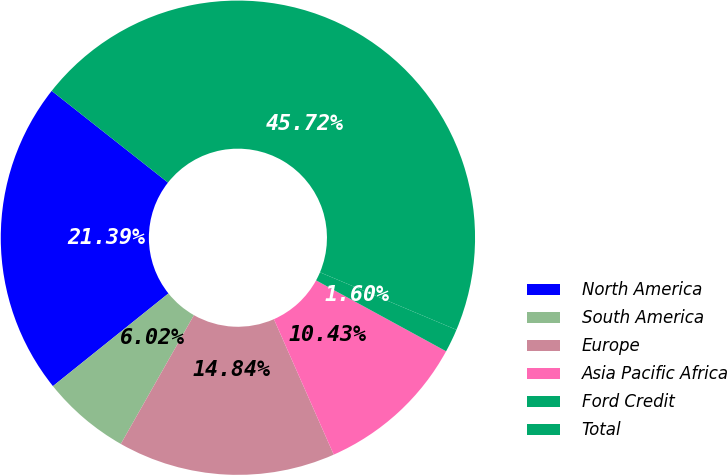Convert chart. <chart><loc_0><loc_0><loc_500><loc_500><pie_chart><fcel>North America<fcel>South America<fcel>Europe<fcel>Asia Pacific Africa<fcel>Ford Credit<fcel>Total<nl><fcel>21.39%<fcel>6.02%<fcel>14.84%<fcel>10.43%<fcel>1.6%<fcel>45.72%<nl></chart> 